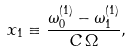<formula> <loc_0><loc_0><loc_500><loc_500>x _ { 1 } \equiv \frac { \omega ^ { ( 1 ) } _ { 0 } - \omega ^ { ( 1 ) } _ { 1 } } { C \, \Omega } ,</formula> 